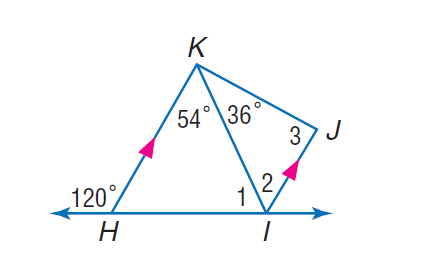Answer the mathemtical geometry problem and directly provide the correct option letter.
Question: If K H is parallel to J I, find the measure of \angle 1.
Choices: A: 23 B: 34 C: 66 D: 67 C 